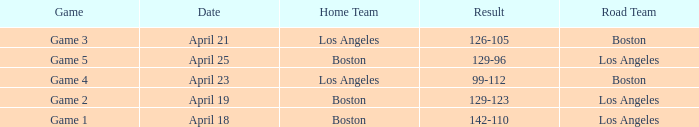Can you give me this table as a dict? {'header': ['Game', 'Date', 'Home Team', 'Result', 'Road Team'], 'rows': [['Game 3', 'April 21', 'Los Angeles', '126-105', 'Boston'], ['Game 5', 'April 25', 'Boston', '129-96', 'Los Angeles'], ['Game 4', 'April 23', 'Los Angeles', '99-112', 'Boston'], ['Game 2', 'April 19', 'Boston', '129-123', 'Los Angeles'], ['Game 1', 'April 18', 'Boston', '142-110', 'Los Angeles']]} WHAT IS THE HOME TEAM ON APRIL 25? Boston. 